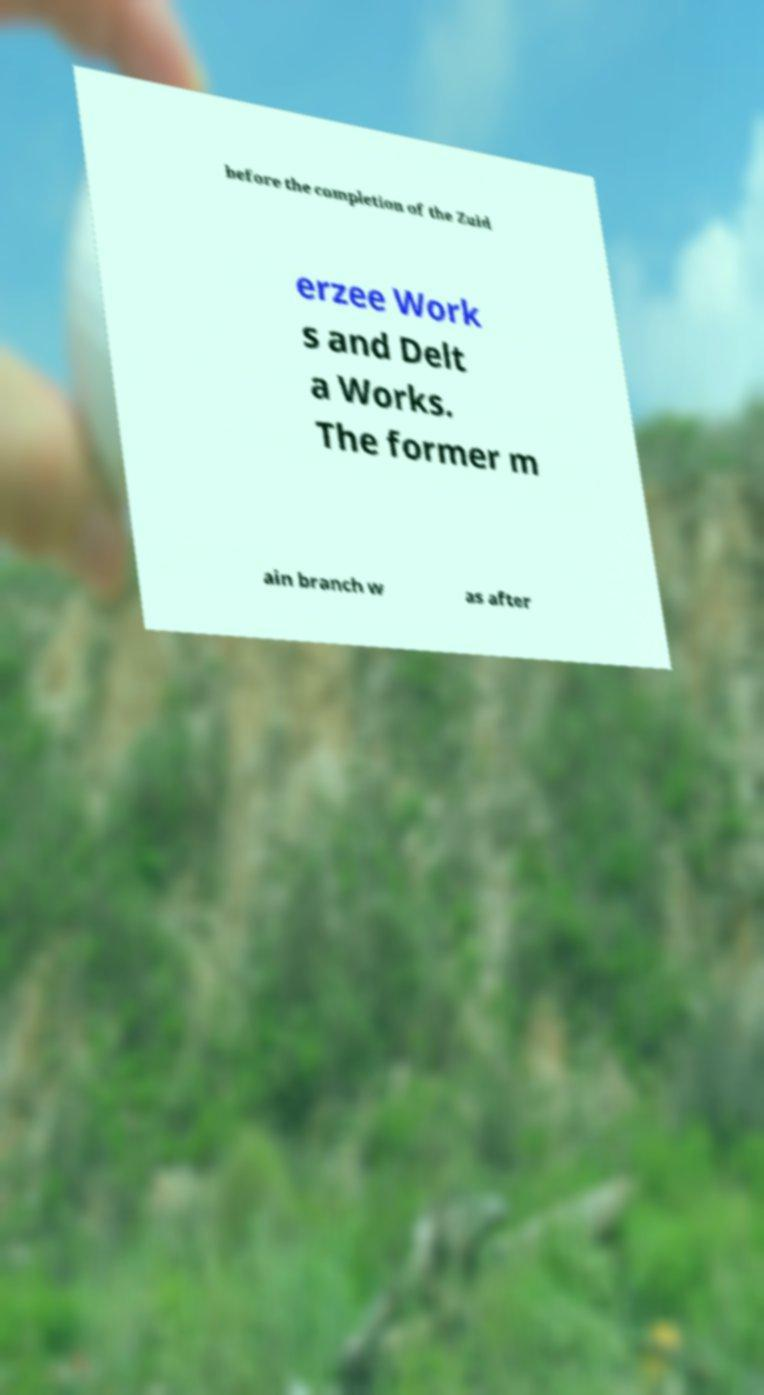There's text embedded in this image that I need extracted. Can you transcribe it verbatim? before the completion of the Zuid erzee Work s and Delt a Works. The former m ain branch w as after 